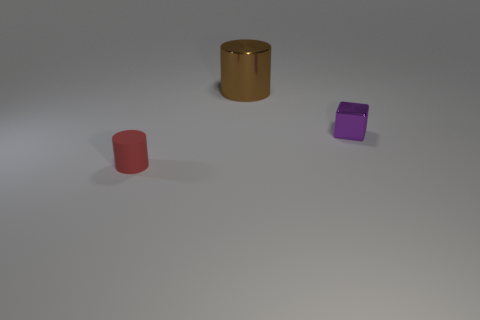What material is the large object?
Give a very brief answer. Metal. How many metallic objects are there?
Your response must be concise. 2. There is a thing that is on the left side of the tiny purple object and behind the small matte cylinder; what is its size?
Offer a terse response. Large. What shape is the matte object that is the same size as the cube?
Give a very brief answer. Cylinder. There is a cylinder that is right of the small matte cylinder; are there any rubber objects that are in front of it?
Your answer should be compact. Yes. What color is the metallic thing that is the same shape as the red rubber object?
Your response must be concise. Brown. How many things are either small objects on the left side of the brown thing or small objects?
Offer a very short reply. 2. What material is the cylinder behind the tiny red object in front of the cylinder behind the purple metal block made of?
Your answer should be very brief. Metal. Is the number of brown things right of the rubber cylinder greater than the number of large brown metallic things that are in front of the large brown object?
Keep it short and to the point. Yes. How many cylinders are tiny brown shiny things or large things?
Offer a terse response. 1. 